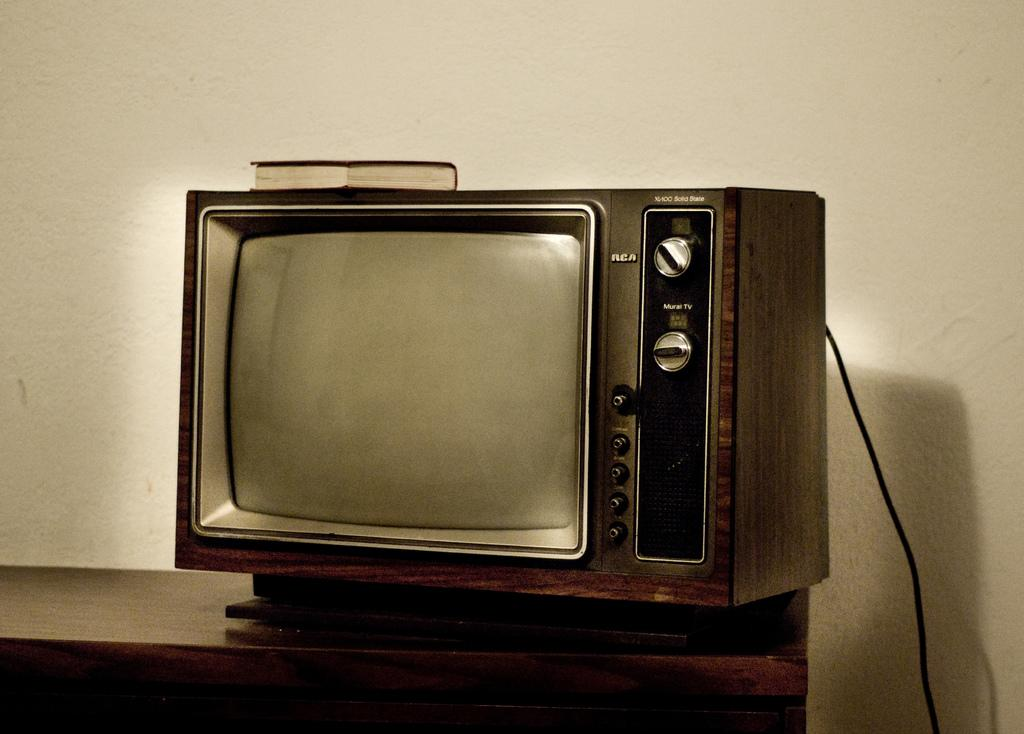<image>
Relay a brief, clear account of the picture shown. a T.V. set that has RCA wrote on it 